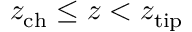<formula> <loc_0><loc_0><loc_500><loc_500>z _ { c h } \leq z < z _ { t i p }</formula> 